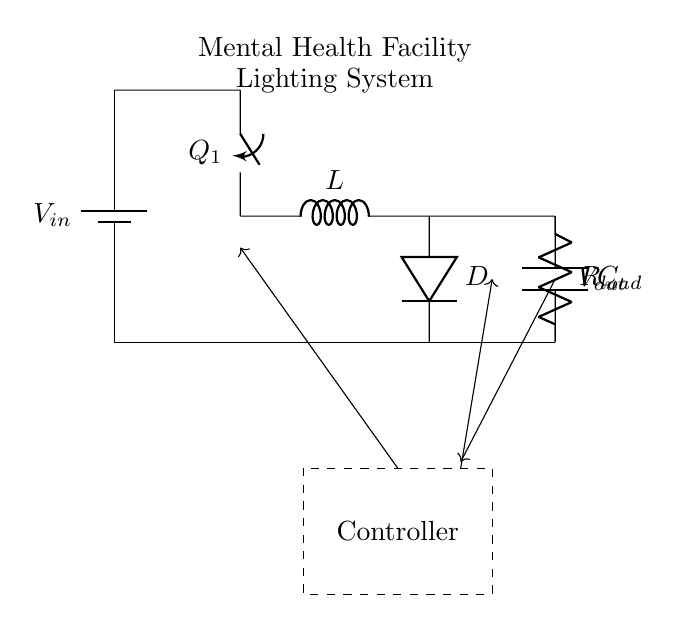What type of circuit is this? This circuit is a switching regulator circuit, designed to convert a higher input voltage to a lower output voltage efficiently. The presence of a switch, diode, inductor, and capacitor are key characteristics of a switching regulator.
Answer: switching regulator What component is labeled as Q1? Q1 in the diagram represents a switch, which is used to control the flow of current in the circuit. It opens and closes to regulate the energy supplied to the load.
Answer: switch What does the inductor do in the circuit? The inductor stores energy when the switch is closed and releases it to maintain a stable output voltage when the switch is open. This action smooths out the current and helps provide the desired voltage to the load.
Answer: stores energy What is the function of the capacitor? The capacitor in this circuit smooths the output voltage by filtering any ripples, providing a more stable voltage to the load. It charges and discharges to maintain a constant voltage during switching operations.
Answer: smooth output What is the role of the controller? The controller manages the operation of the switch to regulate the output voltage by adjusting the switch's timing, ensuring that the output remains stable despite variations in load or input voltage.
Answer: regulates voltage What is the output voltage indicated in the diagram? The output voltage, labeled as Vout, is the voltage delivered to the load after the energy has been processed by the switching regulator circuit. In a well-designed switching regulator, the output voltage should match the requirements of the lighting system.
Answer: Vout How does feedback work in this circuit? Feedback in this circuit is used to monitor the output voltage and return that information to the controller. If Vout deviates from its desired value, the controller adjusts the switch timing to maintain the output voltage within specified limits, ensuring optimal performance.
Answer: monitors output 